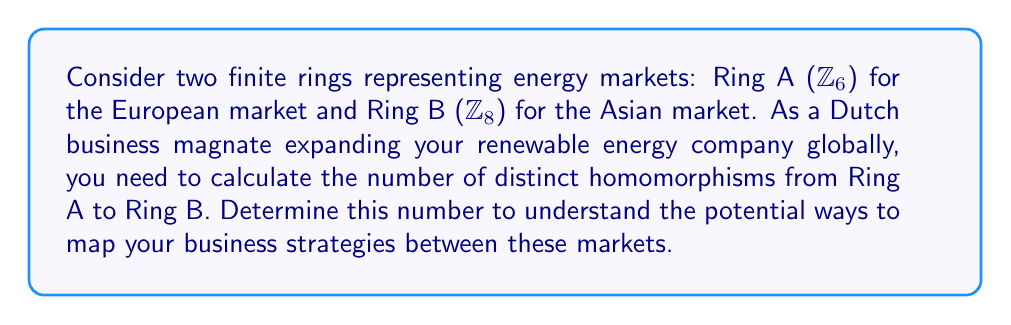Give your solution to this math problem. To solve this problem, we need to follow these steps:

1) Recall that a ring homomorphism $f: \mathbb{Z}_6 \to \mathbb{Z}_8$ must satisfy:
   a) $f(0) = 0$
   b) $f(a+b) = f(a) + f(b)$ for all $a,b \in \mathbb{Z}_6$
   c) $f(ab) = f(a)f(b)$ for all $a,b \in \mathbb{Z}_6$

2) In $\mathbb{Z}_6$, the element 1 generates the additive group. So, if we know $f(1)$, we can determine the entire homomorphism.

3) Let $f(1) = x \in \mathbb{Z}_8$. Then:
   $f(2) = f(1+1) = f(1) + f(1) = x + x = 2x$
   $f(3) = f(1+1+1) = x + x + x = 3x$
   $f(4) = 4x$
   $f(5) = 5x$

4) For the homomorphism to be well-defined, we must have:
   $f(0) = f(6) = 6x = 0$ in $\mathbb{Z}_8$

5) This means $8$ must divide $6x$, or equivalently, $4$ must divide $3x$.

6) The possible values for $x$ that satisfy this condition are 0 and 4 in $\mathbb{Z}_8$.

7) We can verify that both of these values indeed give valid homomorphisms:
   - If $x = 0$, we get the zero homomorphism (maps everything to 0)
   - If $x = 4$, we get the homomorphism that maps odd elements to 4 and even elements to 0

Therefore, there are exactly 2 distinct homomorphisms from $\mathbb{Z}_6$ to $\mathbb{Z}_8$.
Answer: 2 